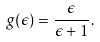Convert formula to latex. <formula><loc_0><loc_0><loc_500><loc_500>g ( \epsilon ) = \frac { \epsilon } { \epsilon + 1 } .</formula> 